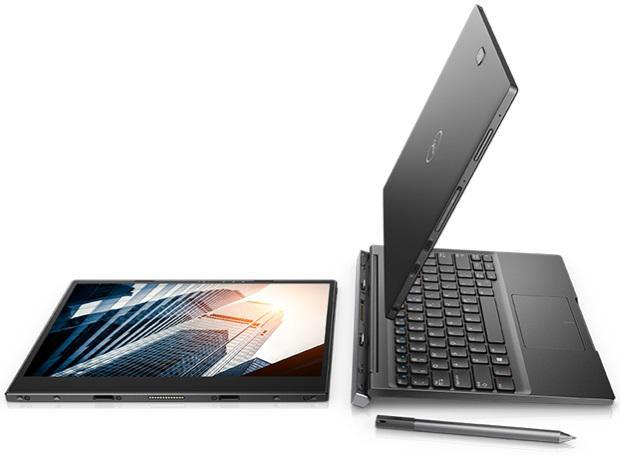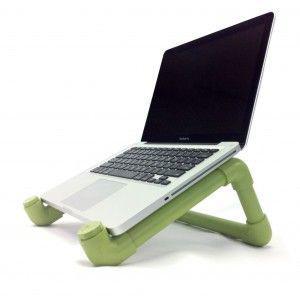The first image is the image on the left, the second image is the image on the right. Evaluate the accuracy of this statement regarding the images: "In the left image, there's a laptop by itself.". Is it true? Answer yes or no. No. The first image is the image on the left, the second image is the image on the right. Evaluate the accuracy of this statement regarding the images: "There is one cord visible.". Is it true? Answer yes or no. No. 